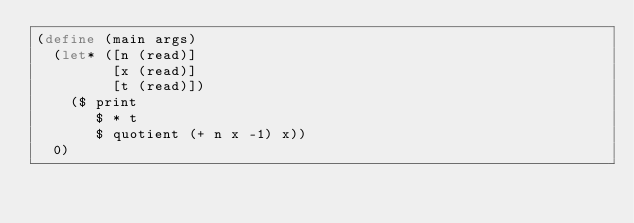Convert code to text. <code><loc_0><loc_0><loc_500><loc_500><_Scheme_>(define (main args)
  (let* ([n (read)]
         [x (read)]
         [t (read)])
    ($ print
       $ * t
       $ quotient (+ n x -1) x))
  0)
</code> 